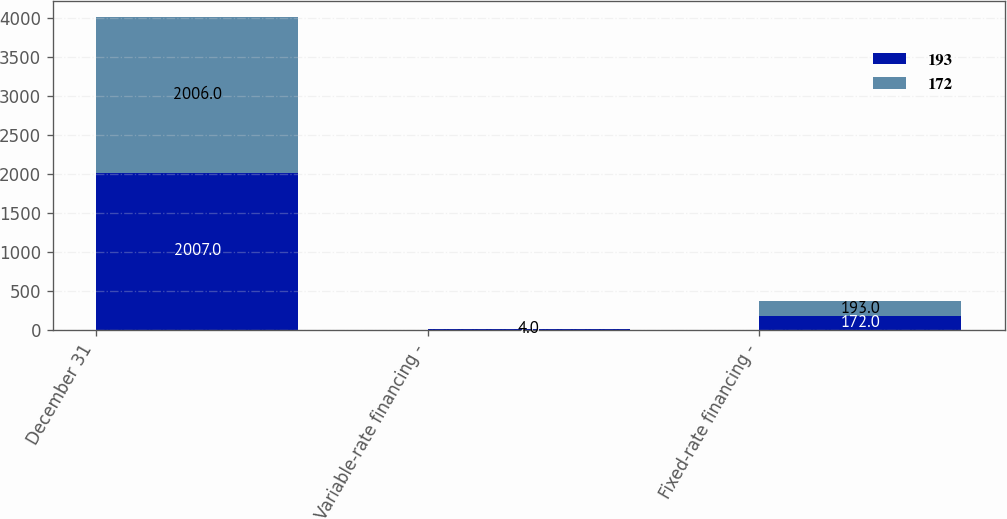Convert chart to OTSL. <chart><loc_0><loc_0><loc_500><loc_500><stacked_bar_chart><ecel><fcel>December 31<fcel>Variable-rate financing -<fcel>Fixed-rate financing -<nl><fcel>193<fcel>2007<fcel>2<fcel>172<nl><fcel>172<fcel>2006<fcel>4<fcel>193<nl></chart> 